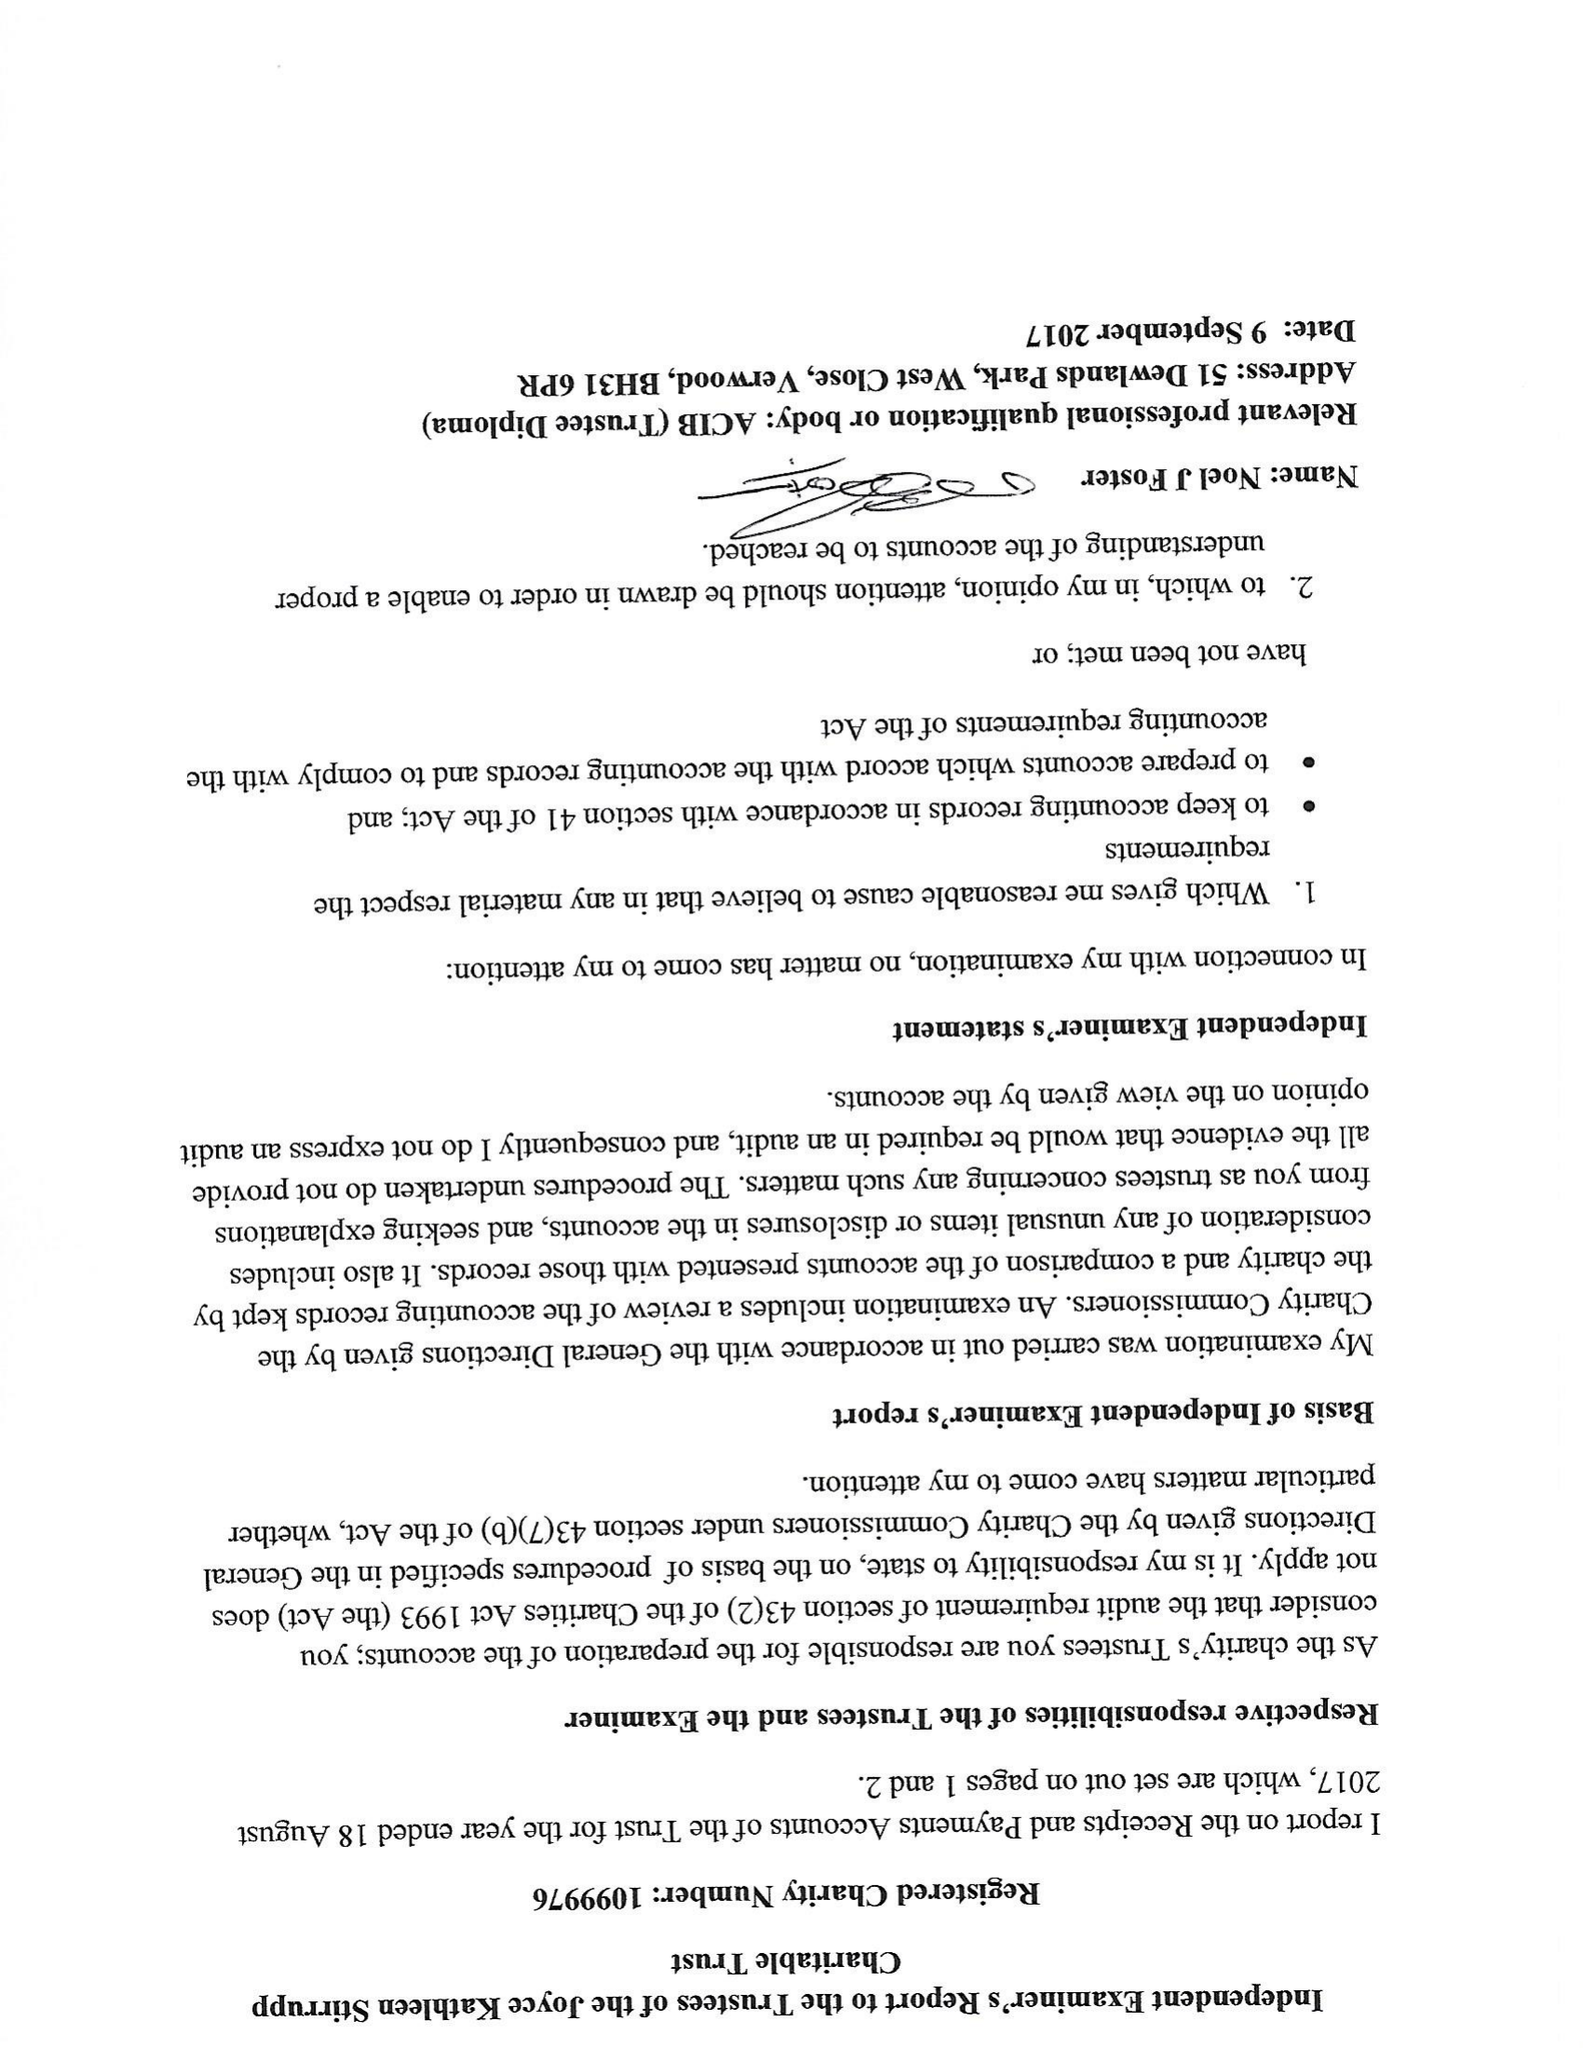What is the value for the charity_name?
Answer the question using a single word or phrase. The Miss J K Stirrup Charity Trust 